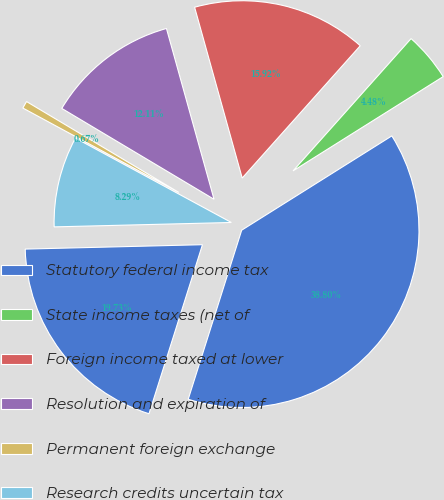Convert chart to OTSL. <chart><loc_0><loc_0><loc_500><loc_500><pie_chart><fcel>Statutory federal income tax<fcel>State income taxes (net of<fcel>Foreign income taxed at lower<fcel>Resolution and expiration of<fcel>Permanent foreign exchange<fcel>Research credits uncertain tax<fcel>Effective income tax rate<nl><fcel>38.8%<fcel>4.48%<fcel>15.92%<fcel>12.11%<fcel>0.67%<fcel>8.29%<fcel>19.73%<nl></chart> 